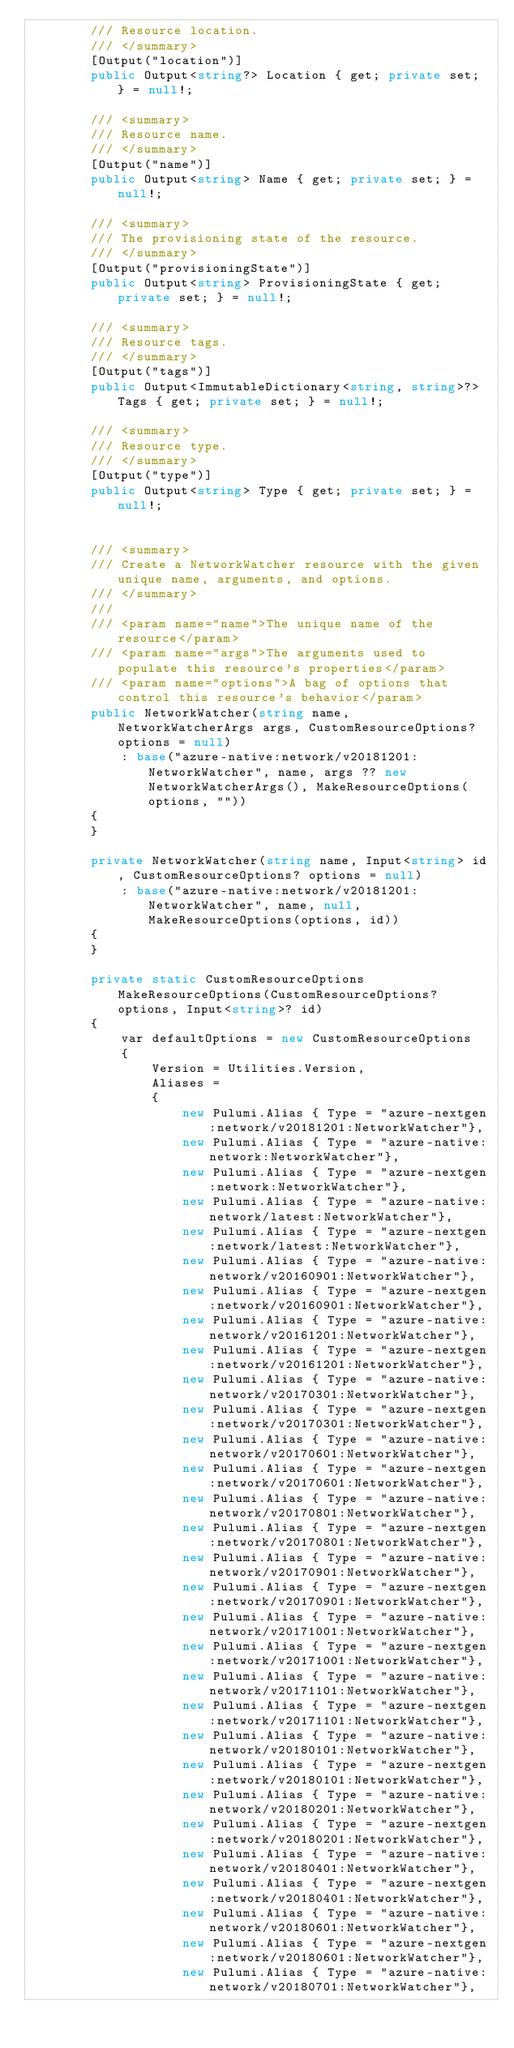Convert code to text. <code><loc_0><loc_0><loc_500><loc_500><_C#_>        /// Resource location.
        /// </summary>
        [Output("location")]
        public Output<string?> Location { get; private set; } = null!;

        /// <summary>
        /// Resource name.
        /// </summary>
        [Output("name")]
        public Output<string> Name { get; private set; } = null!;

        /// <summary>
        /// The provisioning state of the resource.
        /// </summary>
        [Output("provisioningState")]
        public Output<string> ProvisioningState { get; private set; } = null!;

        /// <summary>
        /// Resource tags.
        /// </summary>
        [Output("tags")]
        public Output<ImmutableDictionary<string, string>?> Tags { get; private set; } = null!;

        /// <summary>
        /// Resource type.
        /// </summary>
        [Output("type")]
        public Output<string> Type { get; private set; } = null!;


        /// <summary>
        /// Create a NetworkWatcher resource with the given unique name, arguments, and options.
        /// </summary>
        ///
        /// <param name="name">The unique name of the resource</param>
        /// <param name="args">The arguments used to populate this resource's properties</param>
        /// <param name="options">A bag of options that control this resource's behavior</param>
        public NetworkWatcher(string name, NetworkWatcherArgs args, CustomResourceOptions? options = null)
            : base("azure-native:network/v20181201:NetworkWatcher", name, args ?? new NetworkWatcherArgs(), MakeResourceOptions(options, ""))
        {
        }

        private NetworkWatcher(string name, Input<string> id, CustomResourceOptions? options = null)
            : base("azure-native:network/v20181201:NetworkWatcher", name, null, MakeResourceOptions(options, id))
        {
        }

        private static CustomResourceOptions MakeResourceOptions(CustomResourceOptions? options, Input<string>? id)
        {
            var defaultOptions = new CustomResourceOptions
            {
                Version = Utilities.Version,
                Aliases =
                {
                    new Pulumi.Alias { Type = "azure-nextgen:network/v20181201:NetworkWatcher"},
                    new Pulumi.Alias { Type = "azure-native:network:NetworkWatcher"},
                    new Pulumi.Alias { Type = "azure-nextgen:network:NetworkWatcher"},
                    new Pulumi.Alias { Type = "azure-native:network/latest:NetworkWatcher"},
                    new Pulumi.Alias { Type = "azure-nextgen:network/latest:NetworkWatcher"},
                    new Pulumi.Alias { Type = "azure-native:network/v20160901:NetworkWatcher"},
                    new Pulumi.Alias { Type = "azure-nextgen:network/v20160901:NetworkWatcher"},
                    new Pulumi.Alias { Type = "azure-native:network/v20161201:NetworkWatcher"},
                    new Pulumi.Alias { Type = "azure-nextgen:network/v20161201:NetworkWatcher"},
                    new Pulumi.Alias { Type = "azure-native:network/v20170301:NetworkWatcher"},
                    new Pulumi.Alias { Type = "azure-nextgen:network/v20170301:NetworkWatcher"},
                    new Pulumi.Alias { Type = "azure-native:network/v20170601:NetworkWatcher"},
                    new Pulumi.Alias { Type = "azure-nextgen:network/v20170601:NetworkWatcher"},
                    new Pulumi.Alias { Type = "azure-native:network/v20170801:NetworkWatcher"},
                    new Pulumi.Alias { Type = "azure-nextgen:network/v20170801:NetworkWatcher"},
                    new Pulumi.Alias { Type = "azure-native:network/v20170901:NetworkWatcher"},
                    new Pulumi.Alias { Type = "azure-nextgen:network/v20170901:NetworkWatcher"},
                    new Pulumi.Alias { Type = "azure-native:network/v20171001:NetworkWatcher"},
                    new Pulumi.Alias { Type = "azure-nextgen:network/v20171001:NetworkWatcher"},
                    new Pulumi.Alias { Type = "azure-native:network/v20171101:NetworkWatcher"},
                    new Pulumi.Alias { Type = "azure-nextgen:network/v20171101:NetworkWatcher"},
                    new Pulumi.Alias { Type = "azure-native:network/v20180101:NetworkWatcher"},
                    new Pulumi.Alias { Type = "azure-nextgen:network/v20180101:NetworkWatcher"},
                    new Pulumi.Alias { Type = "azure-native:network/v20180201:NetworkWatcher"},
                    new Pulumi.Alias { Type = "azure-nextgen:network/v20180201:NetworkWatcher"},
                    new Pulumi.Alias { Type = "azure-native:network/v20180401:NetworkWatcher"},
                    new Pulumi.Alias { Type = "azure-nextgen:network/v20180401:NetworkWatcher"},
                    new Pulumi.Alias { Type = "azure-native:network/v20180601:NetworkWatcher"},
                    new Pulumi.Alias { Type = "azure-nextgen:network/v20180601:NetworkWatcher"},
                    new Pulumi.Alias { Type = "azure-native:network/v20180701:NetworkWatcher"},</code> 